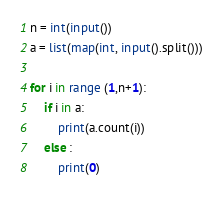Convert code to text. <code><loc_0><loc_0><loc_500><loc_500><_Python_>n = int(input())
a = list(map(int, input().split()))

for i in range (1,n+1):
    if i in a:
        print(a.count(i))
    else :
        print(0)</code> 